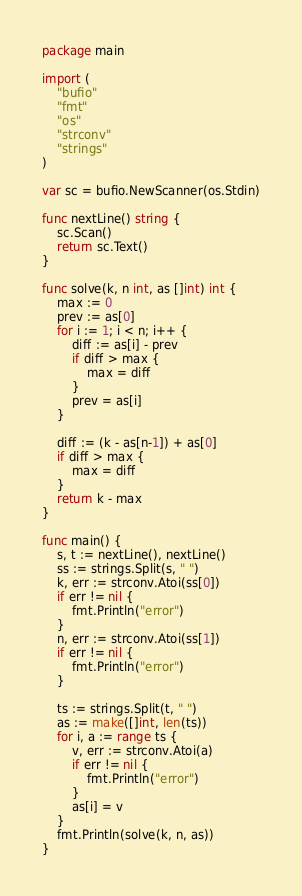Convert code to text. <code><loc_0><loc_0><loc_500><loc_500><_Go_>package main

import (
	"bufio"
	"fmt"
	"os"
	"strconv"
	"strings"
)

var sc = bufio.NewScanner(os.Stdin)

func nextLine() string {
	sc.Scan()
	return sc.Text()
}

func solve(k, n int, as []int) int {
	max := 0
	prev := as[0]
	for i := 1; i < n; i++ {
		diff := as[i] - prev
		if diff > max {
			max = diff
		}
		prev = as[i]
	}

	diff := (k - as[n-1]) + as[0]
	if diff > max {
		max = diff
	}
	return k - max
}

func main() {
	s, t := nextLine(), nextLine()
	ss := strings.Split(s, " ")
	k, err := strconv.Atoi(ss[0])
	if err != nil {
		fmt.Println("error")
	}
	n, err := strconv.Atoi(ss[1])
	if err != nil {
		fmt.Println("error")
	}

	ts := strings.Split(t, " ")
	as := make([]int, len(ts))
	for i, a := range ts {
		v, err := strconv.Atoi(a)
		if err != nil {
			fmt.Println("error")
		}
		as[i] = v
	}
	fmt.Println(solve(k, n, as))
}
</code> 